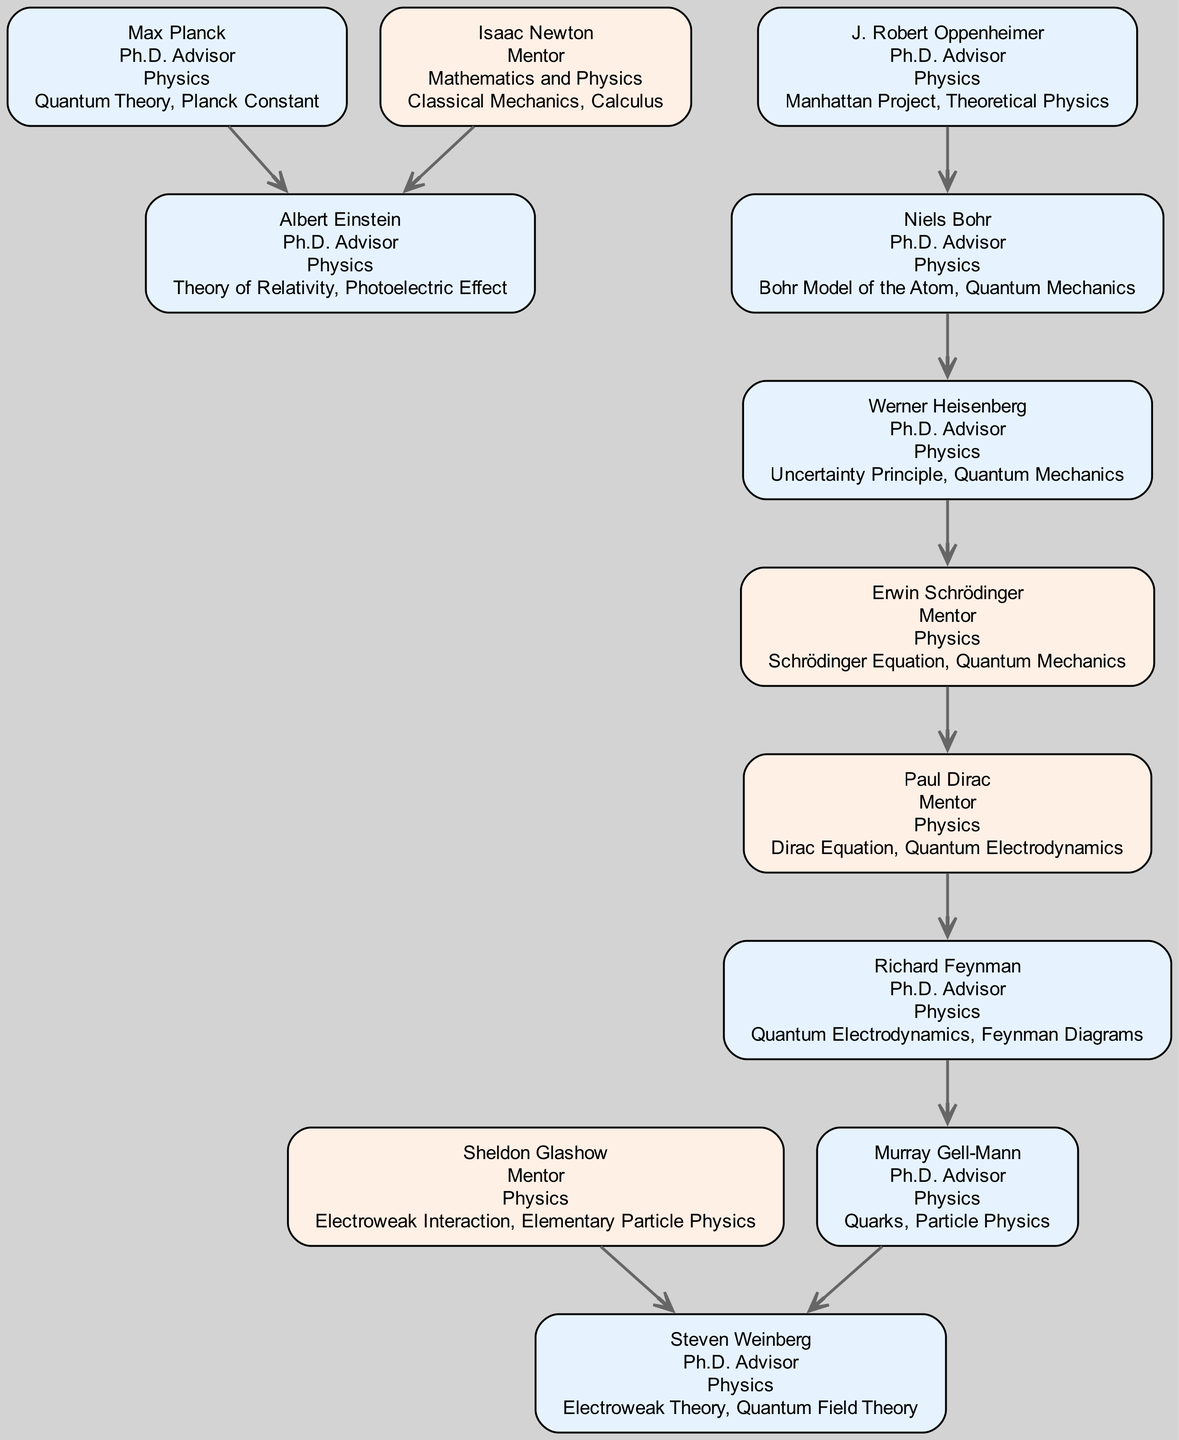What is the total number of individuals represented in the diagram? The diagram lists 11 nodes representing individuals in the academic lineage.
Answer: 11 Who is the Ph.D. advisor of Richard Feynman? The edge leading to Richard Feynman indicates that Paul Dirac is his Ph.D. advisor.
Answer: Paul Dirac Which individual is both a mentor and has contributed to Quantum Mechanics? Erwin Schrödinger is categorized as a mentor and is known for contributions to Quantum Mechanics.
Answer: Erwin Schrödinger How many Ph.D. advisors did Albert Einstein have? The diagram shows two edges leading to Albert Einstein, indicating he had two Ph.D. advisors: Max Planck and Isaac Newton.
Answer: 2 Who mentored both Steven Weinberg and Richard Feynman? By assessing the edges, it can be seen that Murray Gell-Mann is the mentor of Richard Feynman and is also directly connected to Steven Weinberg.
Answer: Murray Gell-Mann What contributions are listed for J. Robert Oppenheimer? J. Robert Oppenheimer has two contributions: Manhattan Project and Theoretical Physics, directly noted in the node description.
Answer: Manhattan Project, Theoretical Physics Who is the most recent advisor in the lineage traced from Isaac Newton? Following the edges from Isaac Newton down through the lineage, the most recent individual is Albert Einstein, who is directly connected through nodes.
Answer: Albert Einstein Which individuals are connected through the same Ph.D. advisor? Richard Feynman and Murray Gell-Mann are connected through Paul Dirac as their Ph.D. advisor.
Answer: Richard Feynman, Murray Gell-Mann How many contributions did Sheldon Glashow make? The edges indicate only one connection leading to Steven Weinberg, and the contributions for Sheldon Glashow are summarized in his node description.
Answer: 2 